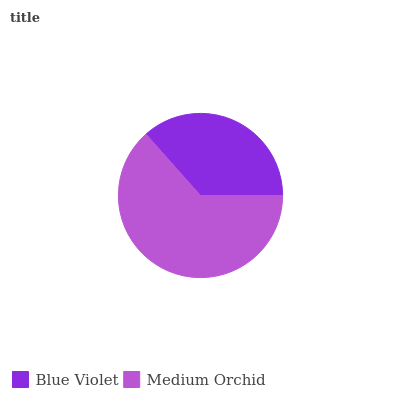Is Blue Violet the minimum?
Answer yes or no. Yes. Is Medium Orchid the maximum?
Answer yes or no. Yes. Is Medium Orchid the minimum?
Answer yes or no. No. Is Medium Orchid greater than Blue Violet?
Answer yes or no. Yes. Is Blue Violet less than Medium Orchid?
Answer yes or no. Yes. Is Blue Violet greater than Medium Orchid?
Answer yes or no. No. Is Medium Orchid less than Blue Violet?
Answer yes or no. No. Is Medium Orchid the high median?
Answer yes or no. Yes. Is Blue Violet the low median?
Answer yes or no. Yes. Is Blue Violet the high median?
Answer yes or no. No. Is Medium Orchid the low median?
Answer yes or no. No. 